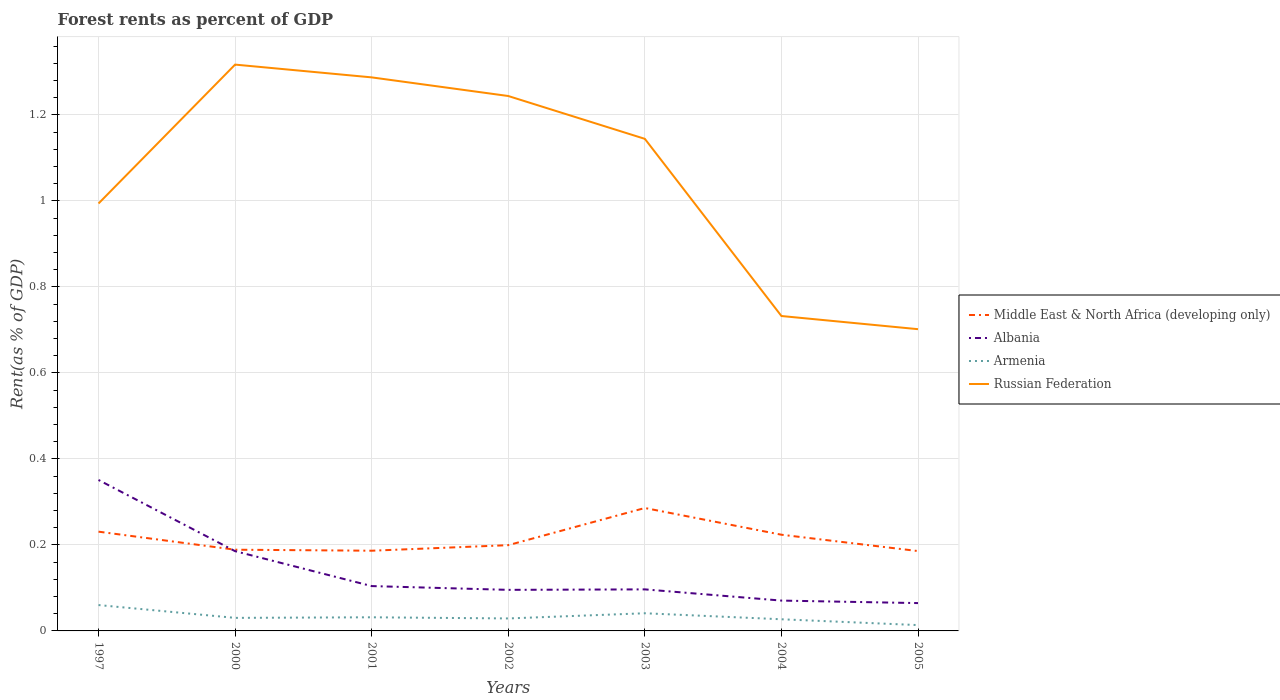Does the line corresponding to Albania intersect with the line corresponding to Russian Federation?
Offer a very short reply. No. Across all years, what is the maximum forest rent in Albania?
Your answer should be very brief. 0.06. What is the total forest rent in Russian Federation in the graph?
Offer a terse response. 0.1. What is the difference between the highest and the second highest forest rent in Middle East & North Africa (developing only)?
Keep it short and to the point. 0.1. How many years are there in the graph?
Provide a succinct answer. 7. What is the difference between two consecutive major ticks on the Y-axis?
Provide a short and direct response. 0.2. Are the values on the major ticks of Y-axis written in scientific E-notation?
Your answer should be very brief. No. How many legend labels are there?
Keep it short and to the point. 4. How are the legend labels stacked?
Offer a terse response. Vertical. What is the title of the graph?
Your response must be concise. Forest rents as percent of GDP. What is the label or title of the X-axis?
Offer a terse response. Years. What is the label or title of the Y-axis?
Your response must be concise. Rent(as % of GDP). What is the Rent(as % of GDP) in Middle East & North Africa (developing only) in 1997?
Keep it short and to the point. 0.23. What is the Rent(as % of GDP) in Albania in 1997?
Ensure brevity in your answer.  0.35. What is the Rent(as % of GDP) in Armenia in 1997?
Give a very brief answer. 0.06. What is the Rent(as % of GDP) of Russian Federation in 1997?
Provide a succinct answer. 0.99. What is the Rent(as % of GDP) in Middle East & North Africa (developing only) in 2000?
Make the answer very short. 0.19. What is the Rent(as % of GDP) in Albania in 2000?
Give a very brief answer. 0.19. What is the Rent(as % of GDP) of Armenia in 2000?
Your answer should be very brief. 0.03. What is the Rent(as % of GDP) in Russian Federation in 2000?
Provide a succinct answer. 1.32. What is the Rent(as % of GDP) in Middle East & North Africa (developing only) in 2001?
Make the answer very short. 0.19. What is the Rent(as % of GDP) in Albania in 2001?
Your response must be concise. 0.1. What is the Rent(as % of GDP) in Armenia in 2001?
Provide a succinct answer. 0.03. What is the Rent(as % of GDP) of Russian Federation in 2001?
Make the answer very short. 1.29. What is the Rent(as % of GDP) of Middle East & North Africa (developing only) in 2002?
Offer a terse response. 0.2. What is the Rent(as % of GDP) in Albania in 2002?
Keep it short and to the point. 0.1. What is the Rent(as % of GDP) in Armenia in 2002?
Give a very brief answer. 0.03. What is the Rent(as % of GDP) in Russian Federation in 2002?
Ensure brevity in your answer.  1.24. What is the Rent(as % of GDP) of Middle East & North Africa (developing only) in 2003?
Your response must be concise. 0.29. What is the Rent(as % of GDP) in Albania in 2003?
Your response must be concise. 0.1. What is the Rent(as % of GDP) of Armenia in 2003?
Make the answer very short. 0.04. What is the Rent(as % of GDP) in Russian Federation in 2003?
Make the answer very short. 1.14. What is the Rent(as % of GDP) of Middle East & North Africa (developing only) in 2004?
Provide a succinct answer. 0.22. What is the Rent(as % of GDP) in Albania in 2004?
Your answer should be compact. 0.07. What is the Rent(as % of GDP) of Armenia in 2004?
Offer a terse response. 0.03. What is the Rent(as % of GDP) in Russian Federation in 2004?
Ensure brevity in your answer.  0.73. What is the Rent(as % of GDP) of Middle East & North Africa (developing only) in 2005?
Provide a succinct answer. 0.19. What is the Rent(as % of GDP) in Albania in 2005?
Provide a short and direct response. 0.06. What is the Rent(as % of GDP) of Armenia in 2005?
Give a very brief answer. 0.01. What is the Rent(as % of GDP) in Russian Federation in 2005?
Make the answer very short. 0.7. Across all years, what is the maximum Rent(as % of GDP) of Middle East & North Africa (developing only)?
Ensure brevity in your answer.  0.29. Across all years, what is the maximum Rent(as % of GDP) in Albania?
Your response must be concise. 0.35. Across all years, what is the maximum Rent(as % of GDP) in Armenia?
Your answer should be very brief. 0.06. Across all years, what is the maximum Rent(as % of GDP) in Russian Federation?
Your response must be concise. 1.32. Across all years, what is the minimum Rent(as % of GDP) of Middle East & North Africa (developing only)?
Your answer should be compact. 0.19. Across all years, what is the minimum Rent(as % of GDP) in Albania?
Ensure brevity in your answer.  0.06. Across all years, what is the minimum Rent(as % of GDP) of Armenia?
Your response must be concise. 0.01. Across all years, what is the minimum Rent(as % of GDP) in Russian Federation?
Make the answer very short. 0.7. What is the total Rent(as % of GDP) of Middle East & North Africa (developing only) in the graph?
Your answer should be very brief. 1.5. What is the total Rent(as % of GDP) of Albania in the graph?
Provide a succinct answer. 0.97. What is the total Rent(as % of GDP) of Armenia in the graph?
Provide a succinct answer. 0.23. What is the total Rent(as % of GDP) of Russian Federation in the graph?
Make the answer very short. 7.42. What is the difference between the Rent(as % of GDP) in Middle East & North Africa (developing only) in 1997 and that in 2000?
Ensure brevity in your answer.  0.04. What is the difference between the Rent(as % of GDP) of Albania in 1997 and that in 2000?
Make the answer very short. 0.17. What is the difference between the Rent(as % of GDP) of Armenia in 1997 and that in 2000?
Your answer should be very brief. 0.03. What is the difference between the Rent(as % of GDP) of Russian Federation in 1997 and that in 2000?
Provide a succinct answer. -0.32. What is the difference between the Rent(as % of GDP) of Middle East & North Africa (developing only) in 1997 and that in 2001?
Offer a terse response. 0.04. What is the difference between the Rent(as % of GDP) of Albania in 1997 and that in 2001?
Make the answer very short. 0.25. What is the difference between the Rent(as % of GDP) in Armenia in 1997 and that in 2001?
Give a very brief answer. 0.03. What is the difference between the Rent(as % of GDP) in Russian Federation in 1997 and that in 2001?
Your answer should be very brief. -0.29. What is the difference between the Rent(as % of GDP) in Middle East & North Africa (developing only) in 1997 and that in 2002?
Your answer should be very brief. 0.03. What is the difference between the Rent(as % of GDP) in Albania in 1997 and that in 2002?
Make the answer very short. 0.26. What is the difference between the Rent(as % of GDP) in Armenia in 1997 and that in 2002?
Your answer should be compact. 0.03. What is the difference between the Rent(as % of GDP) of Middle East & North Africa (developing only) in 1997 and that in 2003?
Make the answer very short. -0.06. What is the difference between the Rent(as % of GDP) in Albania in 1997 and that in 2003?
Provide a succinct answer. 0.25. What is the difference between the Rent(as % of GDP) in Armenia in 1997 and that in 2003?
Provide a succinct answer. 0.02. What is the difference between the Rent(as % of GDP) of Russian Federation in 1997 and that in 2003?
Provide a succinct answer. -0.15. What is the difference between the Rent(as % of GDP) in Middle East & North Africa (developing only) in 1997 and that in 2004?
Your response must be concise. 0.01. What is the difference between the Rent(as % of GDP) in Albania in 1997 and that in 2004?
Make the answer very short. 0.28. What is the difference between the Rent(as % of GDP) of Armenia in 1997 and that in 2004?
Provide a succinct answer. 0.03. What is the difference between the Rent(as % of GDP) of Russian Federation in 1997 and that in 2004?
Offer a terse response. 0.26. What is the difference between the Rent(as % of GDP) of Middle East & North Africa (developing only) in 1997 and that in 2005?
Offer a terse response. 0.05. What is the difference between the Rent(as % of GDP) in Albania in 1997 and that in 2005?
Provide a short and direct response. 0.29. What is the difference between the Rent(as % of GDP) of Armenia in 1997 and that in 2005?
Provide a succinct answer. 0.05. What is the difference between the Rent(as % of GDP) of Russian Federation in 1997 and that in 2005?
Your response must be concise. 0.29. What is the difference between the Rent(as % of GDP) in Middle East & North Africa (developing only) in 2000 and that in 2001?
Make the answer very short. 0. What is the difference between the Rent(as % of GDP) in Albania in 2000 and that in 2001?
Provide a short and direct response. 0.08. What is the difference between the Rent(as % of GDP) in Armenia in 2000 and that in 2001?
Your answer should be very brief. -0. What is the difference between the Rent(as % of GDP) in Russian Federation in 2000 and that in 2001?
Your answer should be compact. 0.03. What is the difference between the Rent(as % of GDP) in Middle East & North Africa (developing only) in 2000 and that in 2002?
Provide a succinct answer. -0.01. What is the difference between the Rent(as % of GDP) of Albania in 2000 and that in 2002?
Your response must be concise. 0.09. What is the difference between the Rent(as % of GDP) in Armenia in 2000 and that in 2002?
Ensure brevity in your answer.  0. What is the difference between the Rent(as % of GDP) of Russian Federation in 2000 and that in 2002?
Provide a succinct answer. 0.07. What is the difference between the Rent(as % of GDP) in Middle East & North Africa (developing only) in 2000 and that in 2003?
Provide a short and direct response. -0.1. What is the difference between the Rent(as % of GDP) of Albania in 2000 and that in 2003?
Provide a succinct answer. 0.09. What is the difference between the Rent(as % of GDP) of Armenia in 2000 and that in 2003?
Your answer should be very brief. -0.01. What is the difference between the Rent(as % of GDP) of Russian Federation in 2000 and that in 2003?
Your answer should be very brief. 0.17. What is the difference between the Rent(as % of GDP) in Middle East & North Africa (developing only) in 2000 and that in 2004?
Provide a succinct answer. -0.03. What is the difference between the Rent(as % of GDP) in Albania in 2000 and that in 2004?
Provide a succinct answer. 0.11. What is the difference between the Rent(as % of GDP) in Armenia in 2000 and that in 2004?
Your answer should be very brief. 0. What is the difference between the Rent(as % of GDP) in Russian Federation in 2000 and that in 2004?
Offer a terse response. 0.58. What is the difference between the Rent(as % of GDP) of Middle East & North Africa (developing only) in 2000 and that in 2005?
Your response must be concise. 0. What is the difference between the Rent(as % of GDP) of Albania in 2000 and that in 2005?
Ensure brevity in your answer.  0.12. What is the difference between the Rent(as % of GDP) in Armenia in 2000 and that in 2005?
Offer a very short reply. 0.02. What is the difference between the Rent(as % of GDP) in Russian Federation in 2000 and that in 2005?
Ensure brevity in your answer.  0.62. What is the difference between the Rent(as % of GDP) of Middle East & North Africa (developing only) in 2001 and that in 2002?
Give a very brief answer. -0.01. What is the difference between the Rent(as % of GDP) in Albania in 2001 and that in 2002?
Offer a terse response. 0.01. What is the difference between the Rent(as % of GDP) of Armenia in 2001 and that in 2002?
Ensure brevity in your answer.  0. What is the difference between the Rent(as % of GDP) in Russian Federation in 2001 and that in 2002?
Keep it short and to the point. 0.04. What is the difference between the Rent(as % of GDP) in Middle East & North Africa (developing only) in 2001 and that in 2003?
Your answer should be very brief. -0.1. What is the difference between the Rent(as % of GDP) of Albania in 2001 and that in 2003?
Offer a very short reply. 0.01. What is the difference between the Rent(as % of GDP) of Armenia in 2001 and that in 2003?
Ensure brevity in your answer.  -0.01. What is the difference between the Rent(as % of GDP) of Russian Federation in 2001 and that in 2003?
Provide a short and direct response. 0.14. What is the difference between the Rent(as % of GDP) of Middle East & North Africa (developing only) in 2001 and that in 2004?
Give a very brief answer. -0.04. What is the difference between the Rent(as % of GDP) of Albania in 2001 and that in 2004?
Keep it short and to the point. 0.03. What is the difference between the Rent(as % of GDP) in Armenia in 2001 and that in 2004?
Give a very brief answer. 0. What is the difference between the Rent(as % of GDP) in Russian Federation in 2001 and that in 2004?
Your response must be concise. 0.56. What is the difference between the Rent(as % of GDP) in Middle East & North Africa (developing only) in 2001 and that in 2005?
Your response must be concise. 0. What is the difference between the Rent(as % of GDP) in Albania in 2001 and that in 2005?
Ensure brevity in your answer.  0.04. What is the difference between the Rent(as % of GDP) of Armenia in 2001 and that in 2005?
Make the answer very short. 0.02. What is the difference between the Rent(as % of GDP) in Russian Federation in 2001 and that in 2005?
Make the answer very short. 0.59. What is the difference between the Rent(as % of GDP) in Middle East & North Africa (developing only) in 2002 and that in 2003?
Keep it short and to the point. -0.09. What is the difference between the Rent(as % of GDP) of Albania in 2002 and that in 2003?
Your response must be concise. -0. What is the difference between the Rent(as % of GDP) of Armenia in 2002 and that in 2003?
Keep it short and to the point. -0.01. What is the difference between the Rent(as % of GDP) of Russian Federation in 2002 and that in 2003?
Offer a terse response. 0.1. What is the difference between the Rent(as % of GDP) in Middle East & North Africa (developing only) in 2002 and that in 2004?
Offer a very short reply. -0.02. What is the difference between the Rent(as % of GDP) of Albania in 2002 and that in 2004?
Give a very brief answer. 0.03. What is the difference between the Rent(as % of GDP) of Armenia in 2002 and that in 2004?
Provide a short and direct response. 0. What is the difference between the Rent(as % of GDP) in Russian Federation in 2002 and that in 2004?
Your response must be concise. 0.51. What is the difference between the Rent(as % of GDP) of Middle East & North Africa (developing only) in 2002 and that in 2005?
Keep it short and to the point. 0.01. What is the difference between the Rent(as % of GDP) of Albania in 2002 and that in 2005?
Offer a very short reply. 0.03. What is the difference between the Rent(as % of GDP) in Armenia in 2002 and that in 2005?
Keep it short and to the point. 0.02. What is the difference between the Rent(as % of GDP) of Russian Federation in 2002 and that in 2005?
Your answer should be very brief. 0.54. What is the difference between the Rent(as % of GDP) of Middle East & North Africa (developing only) in 2003 and that in 2004?
Your answer should be compact. 0.06. What is the difference between the Rent(as % of GDP) in Albania in 2003 and that in 2004?
Your response must be concise. 0.03. What is the difference between the Rent(as % of GDP) in Armenia in 2003 and that in 2004?
Offer a very short reply. 0.01. What is the difference between the Rent(as % of GDP) of Russian Federation in 2003 and that in 2004?
Keep it short and to the point. 0.41. What is the difference between the Rent(as % of GDP) of Middle East & North Africa (developing only) in 2003 and that in 2005?
Keep it short and to the point. 0.1. What is the difference between the Rent(as % of GDP) in Albania in 2003 and that in 2005?
Your response must be concise. 0.03. What is the difference between the Rent(as % of GDP) of Armenia in 2003 and that in 2005?
Give a very brief answer. 0.03. What is the difference between the Rent(as % of GDP) in Russian Federation in 2003 and that in 2005?
Make the answer very short. 0.44. What is the difference between the Rent(as % of GDP) in Middle East & North Africa (developing only) in 2004 and that in 2005?
Your response must be concise. 0.04. What is the difference between the Rent(as % of GDP) in Albania in 2004 and that in 2005?
Provide a short and direct response. 0.01. What is the difference between the Rent(as % of GDP) of Armenia in 2004 and that in 2005?
Give a very brief answer. 0.01. What is the difference between the Rent(as % of GDP) in Russian Federation in 2004 and that in 2005?
Offer a very short reply. 0.03. What is the difference between the Rent(as % of GDP) in Middle East & North Africa (developing only) in 1997 and the Rent(as % of GDP) in Albania in 2000?
Your answer should be very brief. 0.05. What is the difference between the Rent(as % of GDP) of Middle East & North Africa (developing only) in 1997 and the Rent(as % of GDP) of Armenia in 2000?
Give a very brief answer. 0.2. What is the difference between the Rent(as % of GDP) in Middle East & North Africa (developing only) in 1997 and the Rent(as % of GDP) in Russian Federation in 2000?
Offer a terse response. -1.09. What is the difference between the Rent(as % of GDP) in Albania in 1997 and the Rent(as % of GDP) in Armenia in 2000?
Provide a short and direct response. 0.32. What is the difference between the Rent(as % of GDP) in Albania in 1997 and the Rent(as % of GDP) in Russian Federation in 2000?
Offer a very short reply. -0.97. What is the difference between the Rent(as % of GDP) of Armenia in 1997 and the Rent(as % of GDP) of Russian Federation in 2000?
Keep it short and to the point. -1.26. What is the difference between the Rent(as % of GDP) in Middle East & North Africa (developing only) in 1997 and the Rent(as % of GDP) in Albania in 2001?
Keep it short and to the point. 0.13. What is the difference between the Rent(as % of GDP) in Middle East & North Africa (developing only) in 1997 and the Rent(as % of GDP) in Armenia in 2001?
Give a very brief answer. 0.2. What is the difference between the Rent(as % of GDP) of Middle East & North Africa (developing only) in 1997 and the Rent(as % of GDP) of Russian Federation in 2001?
Provide a short and direct response. -1.06. What is the difference between the Rent(as % of GDP) in Albania in 1997 and the Rent(as % of GDP) in Armenia in 2001?
Make the answer very short. 0.32. What is the difference between the Rent(as % of GDP) of Albania in 1997 and the Rent(as % of GDP) of Russian Federation in 2001?
Provide a succinct answer. -0.94. What is the difference between the Rent(as % of GDP) of Armenia in 1997 and the Rent(as % of GDP) of Russian Federation in 2001?
Give a very brief answer. -1.23. What is the difference between the Rent(as % of GDP) of Middle East & North Africa (developing only) in 1997 and the Rent(as % of GDP) of Albania in 2002?
Ensure brevity in your answer.  0.14. What is the difference between the Rent(as % of GDP) of Middle East & North Africa (developing only) in 1997 and the Rent(as % of GDP) of Armenia in 2002?
Provide a succinct answer. 0.2. What is the difference between the Rent(as % of GDP) of Middle East & North Africa (developing only) in 1997 and the Rent(as % of GDP) of Russian Federation in 2002?
Your answer should be very brief. -1.01. What is the difference between the Rent(as % of GDP) of Albania in 1997 and the Rent(as % of GDP) of Armenia in 2002?
Ensure brevity in your answer.  0.32. What is the difference between the Rent(as % of GDP) of Albania in 1997 and the Rent(as % of GDP) of Russian Federation in 2002?
Provide a succinct answer. -0.89. What is the difference between the Rent(as % of GDP) of Armenia in 1997 and the Rent(as % of GDP) of Russian Federation in 2002?
Offer a terse response. -1.18. What is the difference between the Rent(as % of GDP) in Middle East & North Africa (developing only) in 1997 and the Rent(as % of GDP) in Albania in 2003?
Your response must be concise. 0.13. What is the difference between the Rent(as % of GDP) in Middle East & North Africa (developing only) in 1997 and the Rent(as % of GDP) in Armenia in 2003?
Your answer should be compact. 0.19. What is the difference between the Rent(as % of GDP) in Middle East & North Africa (developing only) in 1997 and the Rent(as % of GDP) in Russian Federation in 2003?
Your answer should be compact. -0.91. What is the difference between the Rent(as % of GDP) of Albania in 1997 and the Rent(as % of GDP) of Armenia in 2003?
Offer a terse response. 0.31. What is the difference between the Rent(as % of GDP) of Albania in 1997 and the Rent(as % of GDP) of Russian Federation in 2003?
Your answer should be very brief. -0.79. What is the difference between the Rent(as % of GDP) in Armenia in 1997 and the Rent(as % of GDP) in Russian Federation in 2003?
Your response must be concise. -1.08. What is the difference between the Rent(as % of GDP) in Middle East & North Africa (developing only) in 1997 and the Rent(as % of GDP) in Albania in 2004?
Keep it short and to the point. 0.16. What is the difference between the Rent(as % of GDP) in Middle East & North Africa (developing only) in 1997 and the Rent(as % of GDP) in Armenia in 2004?
Give a very brief answer. 0.2. What is the difference between the Rent(as % of GDP) in Middle East & North Africa (developing only) in 1997 and the Rent(as % of GDP) in Russian Federation in 2004?
Keep it short and to the point. -0.5. What is the difference between the Rent(as % of GDP) of Albania in 1997 and the Rent(as % of GDP) of Armenia in 2004?
Offer a very short reply. 0.32. What is the difference between the Rent(as % of GDP) of Albania in 1997 and the Rent(as % of GDP) of Russian Federation in 2004?
Provide a short and direct response. -0.38. What is the difference between the Rent(as % of GDP) in Armenia in 1997 and the Rent(as % of GDP) in Russian Federation in 2004?
Keep it short and to the point. -0.67. What is the difference between the Rent(as % of GDP) in Middle East & North Africa (developing only) in 1997 and the Rent(as % of GDP) in Albania in 2005?
Provide a short and direct response. 0.17. What is the difference between the Rent(as % of GDP) of Middle East & North Africa (developing only) in 1997 and the Rent(as % of GDP) of Armenia in 2005?
Provide a succinct answer. 0.22. What is the difference between the Rent(as % of GDP) in Middle East & North Africa (developing only) in 1997 and the Rent(as % of GDP) in Russian Federation in 2005?
Give a very brief answer. -0.47. What is the difference between the Rent(as % of GDP) in Albania in 1997 and the Rent(as % of GDP) in Armenia in 2005?
Your answer should be compact. 0.34. What is the difference between the Rent(as % of GDP) in Albania in 1997 and the Rent(as % of GDP) in Russian Federation in 2005?
Make the answer very short. -0.35. What is the difference between the Rent(as % of GDP) of Armenia in 1997 and the Rent(as % of GDP) of Russian Federation in 2005?
Offer a terse response. -0.64. What is the difference between the Rent(as % of GDP) in Middle East & North Africa (developing only) in 2000 and the Rent(as % of GDP) in Albania in 2001?
Give a very brief answer. 0.08. What is the difference between the Rent(as % of GDP) in Middle East & North Africa (developing only) in 2000 and the Rent(as % of GDP) in Armenia in 2001?
Offer a terse response. 0.16. What is the difference between the Rent(as % of GDP) in Middle East & North Africa (developing only) in 2000 and the Rent(as % of GDP) in Russian Federation in 2001?
Provide a short and direct response. -1.1. What is the difference between the Rent(as % of GDP) in Albania in 2000 and the Rent(as % of GDP) in Armenia in 2001?
Your response must be concise. 0.15. What is the difference between the Rent(as % of GDP) of Albania in 2000 and the Rent(as % of GDP) of Russian Federation in 2001?
Provide a short and direct response. -1.1. What is the difference between the Rent(as % of GDP) in Armenia in 2000 and the Rent(as % of GDP) in Russian Federation in 2001?
Give a very brief answer. -1.26. What is the difference between the Rent(as % of GDP) in Middle East & North Africa (developing only) in 2000 and the Rent(as % of GDP) in Albania in 2002?
Offer a very short reply. 0.09. What is the difference between the Rent(as % of GDP) in Middle East & North Africa (developing only) in 2000 and the Rent(as % of GDP) in Armenia in 2002?
Give a very brief answer. 0.16. What is the difference between the Rent(as % of GDP) in Middle East & North Africa (developing only) in 2000 and the Rent(as % of GDP) in Russian Federation in 2002?
Make the answer very short. -1.06. What is the difference between the Rent(as % of GDP) in Albania in 2000 and the Rent(as % of GDP) in Armenia in 2002?
Offer a very short reply. 0.16. What is the difference between the Rent(as % of GDP) in Albania in 2000 and the Rent(as % of GDP) in Russian Federation in 2002?
Your answer should be very brief. -1.06. What is the difference between the Rent(as % of GDP) of Armenia in 2000 and the Rent(as % of GDP) of Russian Federation in 2002?
Give a very brief answer. -1.21. What is the difference between the Rent(as % of GDP) of Middle East & North Africa (developing only) in 2000 and the Rent(as % of GDP) of Albania in 2003?
Your answer should be compact. 0.09. What is the difference between the Rent(as % of GDP) of Middle East & North Africa (developing only) in 2000 and the Rent(as % of GDP) of Armenia in 2003?
Your response must be concise. 0.15. What is the difference between the Rent(as % of GDP) in Middle East & North Africa (developing only) in 2000 and the Rent(as % of GDP) in Russian Federation in 2003?
Give a very brief answer. -0.96. What is the difference between the Rent(as % of GDP) of Albania in 2000 and the Rent(as % of GDP) of Armenia in 2003?
Give a very brief answer. 0.14. What is the difference between the Rent(as % of GDP) of Albania in 2000 and the Rent(as % of GDP) of Russian Federation in 2003?
Offer a very short reply. -0.96. What is the difference between the Rent(as % of GDP) in Armenia in 2000 and the Rent(as % of GDP) in Russian Federation in 2003?
Give a very brief answer. -1.11. What is the difference between the Rent(as % of GDP) in Middle East & North Africa (developing only) in 2000 and the Rent(as % of GDP) in Albania in 2004?
Make the answer very short. 0.12. What is the difference between the Rent(as % of GDP) in Middle East & North Africa (developing only) in 2000 and the Rent(as % of GDP) in Armenia in 2004?
Give a very brief answer. 0.16. What is the difference between the Rent(as % of GDP) in Middle East & North Africa (developing only) in 2000 and the Rent(as % of GDP) in Russian Federation in 2004?
Give a very brief answer. -0.54. What is the difference between the Rent(as % of GDP) in Albania in 2000 and the Rent(as % of GDP) in Armenia in 2004?
Provide a succinct answer. 0.16. What is the difference between the Rent(as % of GDP) of Albania in 2000 and the Rent(as % of GDP) of Russian Federation in 2004?
Provide a short and direct response. -0.55. What is the difference between the Rent(as % of GDP) in Armenia in 2000 and the Rent(as % of GDP) in Russian Federation in 2004?
Ensure brevity in your answer.  -0.7. What is the difference between the Rent(as % of GDP) in Middle East & North Africa (developing only) in 2000 and the Rent(as % of GDP) in Albania in 2005?
Keep it short and to the point. 0.12. What is the difference between the Rent(as % of GDP) in Middle East & North Africa (developing only) in 2000 and the Rent(as % of GDP) in Armenia in 2005?
Your answer should be very brief. 0.18. What is the difference between the Rent(as % of GDP) in Middle East & North Africa (developing only) in 2000 and the Rent(as % of GDP) in Russian Federation in 2005?
Make the answer very short. -0.51. What is the difference between the Rent(as % of GDP) in Albania in 2000 and the Rent(as % of GDP) in Armenia in 2005?
Offer a very short reply. 0.17. What is the difference between the Rent(as % of GDP) of Albania in 2000 and the Rent(as % of GDP) of Russian Federation in 2005?
Your response must be concise. -0.52. What is the difference between the Rent(as % of GDP) in Armenia in 2000 and the Rent(as % of GDP) in Russian Federation in 2005?
Provide a succinct answer. -0.67. What is the difference between the Rent(as % of GDP) of Middle East & North Africa (developing only) in 2001 and the Rent(as % of GDP) of Albania in 2002?
Ensure brevity in your answer.  0.09. What is the difference between the Rent(as % of GDP) of Middle East & North Africa (developing only) in 2001 and the Rent(as % of GDP) of Armenia in 2002?
Offer a very short reply. 0.16. What is the difference between the Rent(as % of GDP) in Middle East & North Africa (developing only) in 2001 and the Rent(as % of GDP) in Russian Federation in 2002?
Make the answer very short. -1.06. What is the difference between the Rent(as % of GDP) in Albania in 2001 and the Rent(as % of GDP) in Armenia in 2002?
Your answer should be compact. 0.08. What is the difference between the Rent(as % of GDP) of Albania in 2001 and the Rent(as % of GDP) of Russian Federation in 2002?
Your answer should be very brief. -1.14. What is the difference between the Rent(as % of GDP) in Armenia in 2001 and the Rent(as % of GDP) in Russian Federation in 2002?
Your answer should be compact. -1.21. What is the difference between the Rent(as % of GDP) in Middle East & North Africa (developing only) in 2001 and the Rent(as % of GDP) in Albania in 2003?
Make the answer very short. 0.09. What is the difference between the Rent(as % of GDP) in Middle East & North Africa (developing only) in 2001 and the Rent(as % of GDP) in Armenia in 2003?
Your response must be concise. 0.15. What is the difference between the Rent(as % of GDP) of Middle East & North Africa (developing only) in 2001 and the Rent(as % of GDP) of Russian Federation in 2003?
Ensure brevity in your answer.  -0.96. What is the difference between the Rent(as % of GDP) of Albania in 2001 and the Rent(as % of GDP) of Armenia in 2003?
Your answer should be very brief. 0.06. What is the difference between the Rent(as % of GDP) of Albania in 2001 and the Rent(as % of GDP) of Russian Federation in 2003?
Your response must be concise. -1.04. What is the difference between the Rent(as % of GDP) in Armenia in 2001 and the Rent(as % of GDP) in Russian Federation in 2003?
Offer a terse response. -1.11. What is the difference between the Rent(as % of GDP) in Middle East & North Africa (developing only) in 2001 and the Rent(as % of GDP) in Albania in 2004?
Your answer should be very brief. 0.12. What is the difference between the Rent(as % of GDP) of Middle East & North Africa (developing only) in 2001 and the Rent(as % of GDP) of Armenia in 2004?
Your answer should be compact. 0.16. What is the difference between the Rent(as % of GDP) of Middle East & North Africa (developing only) in 2001 and the Rent(as % of GDP) of Russian Federation in 2004?
Your response must be concise. -0.55. What is the difference between the Rent(as % of GDP) in Albania in 2001 and the Rent(as % of GDP) in Armenia in 2004?
Offer a very short reply. 0.08. What is the difference between the Rent(as % of GDP) in Albania in 2001 and the Rent(as % of GDP) in Russian Federation in 2004?
Provide a succinct answer. -0.63. What is the difference between the Rent(as % of GDP) in Armenia in 2001 and the Rent(as % of GDP) in Russian Federation in 2004?
Your response must be concise. -0.7. What is the difference between the Rent(as % of GDP) in Middle East & North Africa (developing only) in 2001 and the Rent(as % of GDP) in Albania in 2005?
Offer a very short reply. 0.12. What is the difference between the Rent(as % of GDP) in Middle East & North Africa (developing only) in 2001 and the Rent(as % of GDP) in Armenia in 2005?
Keep it short and to the point. 0.17. What is the difference between the Rent(as % of GDP) in Middle East & North Africa (developing only) in 2001 and the Rent(as % of GDP) in Russian Federation in 2005?
Provide a short and direct response. -0.52. What is the difference between the Rent(as % of GDP) of Albania in 2001 and the Rent(as % of GDP) of Armenia in 2005?
Offer a terse response. 0.09. What is the difference between the Rent(as % of GDP) in Albania in 2001 and the Rent(as % of GDP) in Russian Federation in 2005?
Provide a short and direct response. -0.6. What is the difference between the Rent(as % of GDP) of Armenia in 2001 and the Rent(as % of GDP) of Russian Federation in 2005?
Ensure brevity in your answer.  -0.67. What is the difference between the Rent(as % of GDP) in Middle East & North Africa (developing only) in 2002 and the Rent(as % of GDP) in Albania in 2003?
Provide a short and direct response. 0.1. What is the difference between the Rent(as % of GDP) in Middle East & North Africa (developing only) in 2002 and the Rent(as % of GDP) in Armenia in 2003?
Provide a short and direct response. 0.16. What is the difference between the Rent(as % of GDP) in Middle East & North Africa (developing only) in 2002 and the Rent(as % of GDP) in Russian Federation in 2003?
Provide a short and direct response. -0.95. What is the difference between the Rent(as % of GDP) of Albania in 2002 and the Rent(as % of GDP) of Armenia in 2003?
Ensure brevity in your answer.  0.05. What is the difference between the Rent(as % of GDP) in Albania in 2002 and the Rent(as % of GDP) in Russian Federation in 2003?
Offer a very short reply. -1.05. What is the difference between the Rent(as % of GDP) of Armenia in 2002 and the Rent(as % of GDP) of Russian Federation in 2003?
Offer a very short reply. -1.12. What is the difference between the Rent(as % of GDP) of Middle East & North Africa (developing only) in 2002 and the Rent(as % of GDP) of Albania in 2004?
Make the answer very short. 0.13. What is the difference between the Rent(as % of GDP) in Middle East & North Africa (developing only) in 2002 and the Rent(as % of GDP) in Armenia in 2004?
Your answer should be very brief. 0.17. What is the difference between the Rent(as % of GDP) in Middle East & North Africa (developing only) in 2002 and the Rent(as % of GDP) in Russian Federation in 2004?
Offer a terse response. -0.53. What is the difference between the Rent(as % of GDP) of Albania in 2002 and the Rent(as % of GDP) of Armenia in 2004?
Your answer should be compact. 0.07. What is the difference between the Rent(as % of GDP) in Albania in 2002 and the Rent(as % of GDP) in Russian Federation in 2004?
Ensure brevity in your answer.  -0.64. What is the difference between the Rent(as % of GDP) in Armenia in 2002 and the Rent(as % of GDP) in Russian Federation in 2004?
Make the answer very short. -0.7. What is the difference between the Rent(as % of GDP) in Middle East & North Africa (developing only) in 2002 and the Rent(as % of GDP) in Albania in 2005?
Make the answer very short. 0.13. What is the difference between the Rent(as % of GDP) of Middle East & North Africa (developing only) in 2002 and the Rent(as % of GDP) of Armenia in 2005?
Give a very brief answer. 0.19. What is the difference between the Rent(as % of GDP) of Middle East & North Africa (developing only) in 2002 and the Rent(as % of GDP) of Russian Federation in 2005?
Your answer should be very brief. -0.5. What is the difference between the Rent(as % of GDP) of Albania in 2002 and the Rent(as % of GDP) of Armenia in 2005?
Give a very brief answer. 0.08. What is the difference between the Rent(as % of GDP) in Albania in 2002 and the Rent(as % of GDP) in Russian Federation in 2005?
Provide a succinct answer. -0.61. What is the difference between the Rent(as % of GDP) of Armenia in 2002 and the Rent(as % of GDP) of Russian Federation in 2005?
Offer a terse response. -0.67. What is the difference between the Rent(as % of GDP) of Middle East & North Africa (developing only) in 2003 and the Rent(as % of GDP) of Albania in 2004?
Provide a short and direct response. 0.22. What is the difference between the Rent(as % of GDP) of Middle East & North Africa (developing only) in 2003 and the Rent(as % of GDP) of Armenia in 2004?
Ensure brevity in your answer.  0.26. What is the difference between the Rent(as % of GDP) in Middle East & North Africa (developing only) in 2003 and the Rent(as % of GDP) in Russian Federation in 2004?
Give a very brief answer. -0.45. What is the difference between the Rent(as % of GDP) of Albania in 2003 and the Rent(as % of GDP) of Armenia in 2004?
Ensure brevity in your answer.  0.07. What is the difference between the Rent(as % of GDP) of Albania in 2003 and the Rent(as % of GDP) of Russian Federation in 2004?
Your response must be concise. -0.64. What is the difference between the Rent(as % of GDP) in Armenia in 2003 and the Rent(as % of GDP) in Russian Federation in 2004?
Provide a succinct answer. -0.69. What is the difference between the Rent(as % of GDP) of Middle East & North Africa (developing only) in 2003 and the Rent(as % of GDP) of Albania in 2005?
Keep it short and to the point. 0.22. What is the difference between the Rent(as % of GDP) of Middle East & North Africa (developing only) in 2003 and the Rent(as % of GDP) of Armenia in 2005?
Provide a succinct answer. 0.27. What is the difference between the Rent(as % of GDP) in Middle East & North Africa (developing only) in 2003 and the Rent(as % of GDP) in Russian Federation in 2005?
Offer a very short reply. -0.42. What is the difference between the Rent(as % of GDP) in Albania in 2003 and the Rent(as % of GDP) in Armenia in 2005?
Your answer should be very brief. 0.08. What is the difference between the Rent(as % of GDP) in Albania in 2003 and the Rent(as % of GDP) in Russian Federation in 2005?
Keep it short and to the point. -0.61. What is the difference between the Rent(as % of GDP) of Armenia in 2003 and the Rent(as % of GDP) of Russian Federation in 2005?
Your answer should be very brief. -0.66. What is the difference between the Rent(as % of GDP) in Middle East & North Africa (developing only) in 2004 and the Rent(as % of GDP) in Albania in 2005?
Make the answer very short. 0.16. What is the difference between the Rent(as % of GDP) in Middle East & North Africa (developing only) in 2004 and the Rent(as % of GDP) in Armenia in 2005?
Offer a very short reply. 0.21. What is the difference between the Rent(as % of GDP) in Middle East & North Africa (developing only) in 2004 and the Rent(as % of GDP) in Russian Federation in 2005?
Ensure brevity in your answer.  -0.48. What is the difference between the Rent(as % of GDP) of Albania in 2004 and the Rent(as % of GDP) of Armenia in 2005?
Give a very brief answer. 0.06. What is the difference between the Rent(as % of GDP) in Albania in 2004 and the Rent(as % of GDP) in Russian Federation in 2005?
Ensure brevity in your answer.  -0.63. What is the difference between the Rent(as % of GDP) of Armenia in 2004 and the Rent(as % of GDP) of Russian Federation in 2005?
Your response must be concise. -0.67. What is the average Rent(as % of GDP) of Middle East & North Africa (developing only) per year?
Offer a very short reply. 0.21. What is the average Rent(as % of GDP) in Albania per year?
Give a very brief answer. 0.14. What is the average Rent(as % of GDP) of Russian Federation per year?
Keep it short and to the point. 1.06. In the year 1997, what is the difference between the Rent(as % of GDP) in Middle East & North Africa (developing only) and Rent(as % of GDP) in Albania?
Make the answer very short. -0.12. In the year 1997, what is the difference between the Rent(as % of GDP) in Middle East & North Africa (developing only) and Rent(as % of GDP) in Armenia?
Provide a short and direct response. 0.17. In the year 1997, what is the difference between the Rent(as % of GDP) in Middle East & North Africa (developing only) and Rent(as % of GDP) in Russian Federation?
Offer a very short reply. -0.76. In the year 1997, what is the difference between the Rent(as % of GDP) in Albania and Rent(as % of GDP) in Armenia?
Provide a succinct answer. 0.29. In the year 1997, what is the difference between the Rent(as % of GDP) in Albania and Rent(as % of GDP) in Russian Federation?
Offer a very short reply. -0.64. In the year 1997, what is the difference between the Rent(as % of GDP) in Armenia and Rent(as % of GDP) in Russian Federation?
Provide a succinct answer. -0.93. In the year 2000, what is the difference between the Rent(as % of GDP) of Middle East & North Africa (developing only) and Rent(as % of GDP) of Albania?
Provide a short and direct response. 0. In the year 2000, what is the difference between the Rent(as % of GDP) of Middle East & North Africa (developing only) and Rent(as % of GDP) of Armenia?
Offer a very short reply. 0.16. In the year 2000, what is the difference between the Rent(as % of GDP) of Middle East & North Africa (developing only) and Rent(as % of GDP) of Russian Federation?
Ensure brevity in your answer.  -1.13. In the year 2000, what is the difference between the Rent(as % of GDP) in Albania and Rent(as % of GDP) in Armenia?
Your response must be concise. 0.16. In the year 2000, what is the difference between the Rent(as % of GDP) of Albania and Rent(as % of GDP) of Russian Federation?
Ensure brevity in your answer.  -1.13. In the year 2000, what is the difference between the Rent(as % of GDP) of Armenia and Rent(as % of GDP) of Russian Federation?
Give a very brief answer. -1.29. In the year 2001, what is the difference between the Rent(as % of GDP) of Middle East & North Africa (developing only) and Rent(as % of GDP) of Albania?
Keep it short and to the point. 0.08. In the year 2001, what is the difference between the Rent(as % of GDP) of Middle East & North Africa (developing only) and Rent(as % of GDP) of Armenia?
Provide a succinct answer. 0.15. In the year 2001, what is the difference between the Rent(as % of GDP) of Middle East & North Africa (developing only) and Rent(as % of GDP) of Russian Federation?
Make the answer very short. -1.1. In the year 2001, what is the difference between the Rent(as % of GDP) in Albania and Rent(as % of GDP) in Armenia?
Offer a very short reply. 0.07. In the year 2001, what is the difference between the Rent(as % of GDP) in Albania and Rent(as % of GDP) in Russian Federation?
Ensure brevity in your answer.  -1.18. In the year 2001, what is the difference between the Rent(as % of GDP) of Armenia and Rent(as % of GDP) of Russian Federation?
Ensure brevity in your answer.  -1.26. In the year 2002, what is the difference between the Rent(as % of GDP) of Middle East & North Africa (developing only) and Rent(as % of GDP) of Albania?
Provide a succinct answer. 0.1. In the year 2002, what is the difference between the Rent(as % of GDP) in Middle East & North Africa (developing only) and Rent(as % of GDP) in Armenia?
Keep it short and to the point. 0.17. In the year 2002, what is the difference between the Rent(as % of GDP) of Middle East & North Africa (developing only) and Rent(as % of GDP) of Russian Federation?
Give a very brief answer. -1.04. In the year 2002, what is the difference between the Rent(as % of GDP) in Albania and Rent(as % of GDP) in Armenia?
Give a very brief answer. 0.07. In the year 2002, what is the difference between the Rent(as % of GDP) in Albania and Rent(as % of GDP) in Russian Federation?
Your answer should be compact. -1.15. In the year 2002, what is the difference between the Rent(as % of GDP) in Armenia and Rent(as % of GDP) in Russian Federation?
Provide a succinct answer. -1.22. In the year 2003, what is the difference between the Rent(as % of GDP) in Middle East & North Africa (developing only) and Rent(as % of GDP) in Albania?
Offer a very short reply. 0.19. In the year 2003, what is the difference between the Rent(as % of GDP) in Middle East & North Africa (developing only) and Rent(as % of GDP) in Armenia?
Keep it short and to the point. 0.24. In the year 2003, what is the difference between the Rent(as % of GDP) in Middle East & North Africa (developing only) and Rent(as % of GDP) in Russian Federation?
Give a very brief answer. -0.86. In the year 2003, what is the difference between the Rent(as % of GDP) in Albania and Rent(as % of GDP) in Armenia?
Provide a short and direct response. 0.06. In the year 2003, what is the difference between the Rent(as % of GDP) in Albania and Rent(as % of GDP) in Russian Federation?
Offer a terse response. -1.05. In the year 2003, what is the difference between the Rent(as % of GDP) of Armenia and Rent(as % of GDP) of Russian Federation?
Your answer should be very brief. -1.1. In the year 2004, what is the difference between the Rent(as % of GDP) of Middle East & North Africa (developing only) and Rent(as % of GDP) of Albania?
Give a very brief answer. 0.15. In the year 2004, what is the difference between the Rent(as % of GDP) of Middle East & North Africa (developing only) and Rent(as % of GDP) of Armenia?
Make the answer very short. 0.2. In the year 2004, what is the difference between the Rent(as % of GDP) of Middle East & North Africa (developing only) and Rent(as % of GDP) of Russian Federation?
Your answer should be very brief. -0.51. In the year 2004, what is the difference between the Rent(as % of GDP) of Albania and Rent(as % of GDP) of Armenia?
Your response must be concise. 0.04. In the year 2004, what is the difference between the Rent(as % of GDP) of Albania and Rent(as % of GDP) of Russian Federation?
Your answer should be very brief. -0.66. In the year 2004, what is the difference between the Rent(as % of GDP) in Armenia and Rent(as % of GDP) in Russian Federation?
Offer a very short reply. -0.71. In the year 2005, what is the difference between the Rent(as % of GDP) in Middle East & North Africa (developing only) and Rent(as % of GDP) in Albania?
Give a very brief answer. 0.12. In the year 2005, what is the difference between the Rent(as % of GDP) of Middle East & North Africa (developing only) and Rent(as % of GDP) of Armenia?
Make the answer very short. 0.17. In the year 2005, what is the difference between the Rent(as % of GDP) of Middle East & North Africa (developing only) and Rent(as % of GDP) of Russian Federation?
Your answer should be compact. -0.52. In the year 2005, what is the difference between the Rent(as % of GDP) in Albania and Rent(as % of GDP) in Armenia?
Your answer should be compact. 0.05. In the year 2005, what is the difference between the Rent(as % of GDP) in Albania and Rent(as % of GDP) in Russian Federation?
Offer a very short reply. -0.64. In the year 2005, what is the difference between the Rent(as % of GDP) in Armenia and Rent(as % of GDP) in Russian Federation?
Provide a short and direct response. -0.69. What is the ratio of the Rent(as % of GDP) of Middle East & North Africa (developing only) in 1997 to that in 2000?
Your answer should be compact. 1.22. What is the ratio of the Rent(as % of GDP) of Albania in 1997 to that in 2000?
Provide a succinct answer. 1.89. What is the ratio of the Rent(as % of GDP) of Armenia in 1997 to that in 2000?
Give a very brief answer. 1.98. What is the ratio of the Rent(as % of GDP) in Russian Federation in 1997 to that in 2000?
Keep it short and to the point. 0.75. What is the ratio of the Rent(as % of GDP) in Middle East & North Africa (developing only) in 1997 to that in 2001?
Offer a terse response. 1.24. What is the ratio of the Rent(as % of GDP) in Albania in 1997 to that in 2001?
Offer a terse response. 3.37. What is the ratio of the Rent(as % of GDP) of Armenia in 1997 to that in 2001?
Ensure brevity in your answer.  1.9. What is the ratio of the Rent(as % of GDP) in Russian Federation in 1997 to that in 2001?
Your answer should be very brief. 0.77. What is the ratio of the Rent(as % of GDP) of Middle East & North Africa (developing only) in 1997 to that in 2002?
Keep it short and to the point. 1.16. What is the ratio of the Rent(as % of GDP) of Albania in 1997 to that in 2002?
Your answer should be compact. 3.68. What is the ratio of the Rent(as % of GDP) in Armenia in 1997 to that in 2002?
Make the answer very short. 2.07. What is the ratio of the Rent(as % of GDP) of Russian Federation in 1997 to that in 2002?
Your response must be concise. 0.8. What is the ratio of the Rent(as % of GDP) in Middle East & North Africa (developing only) in 1997 to that in 2003?
Offer a terse response. 0.81. What is the ratio of the Rent(as % of GDP) in Albania in 1997 to that in 2003?
Your answer should be compact. 3.63. What is the ratio of the Rent(as % of GDP) in Armenia in 1997 to that in 2003?
Your answer should be very brief. 1.46. What is the ratio of the Rent(as % of GDP) of Russian Federation in 1997 to that in 2003?
Provide a succinct answer. 0.87. What is the ratio of the Rent(as % of GDP) in Middle East & North Africa (developing only) in 1997 to that in 2004?
Provide a short and direct response. 1.03. What is the ratio of the Rent(as % of GDP) of Albania in 1997 to that in 2004?
Your answer should be very brief. 4.98. What is the ratio of the Rent(as % of GDP) in Armenia in 1997 to that in 2004?
Provide a short and direct response. 2.22. What is the ratio of the Rent(as % of GDP) of Russian Federation in 1997 to that in 2004?
Provide a short and direct response. 1.36. What is the ratio of the Rent(as % of GDP) in Middle East & North Africa (developing only) in 1997 to that in 2005?
Your response must be concise. 1.24. What is the ratio of the Rent(as % of GDP) of Albania in 1997 to that in 2005?
Offer a terse response. 5.42. What is the ratio of the Rent(as % of GDP) of Armenia in 1997 to that in 2005?
Keep it short and to the point. 4.44. What is the ratio of the Rent(as % of GDP) of Russian Federation in 1997 to that in 2005?
Your answer should be very brief. 1.42. What is the ratio of the Rent(as % of GDP) of Middle East & North Africa (developing only) in 2000 to that in 2001?
Offer a terse response. 1.01. What is the ratio of the Rent(as % of GDP) in Albania in 2000 to that in 2001?
Ensure brevity in your answer.  1.78. What is the ratio of the Rent(as % of GDP) in Armenia in 2000 to that in 2001?
Offer a very short reply. 0.96. What is the ratio of the Rent(as % of GDP) in Russian Federation in 2000 to that in 2001?
Your response must be concise. 1.02. What is the ratio of the Rent(as % of GDP) of Middle East & North Africa (developing only) in 2000 to that in 2002?
Your answer should be very brief. 0.95. What is the ratio of the Rent(as % of GDP) in Albania in 2000 to that in 2002?
Make the answer very short. 1.94. What is the ratio of the Rent(as % of GDP) in Armenia in 2000 to that in 2002?
Your answer should be very brief. 1.05. What is the ratio of the Rent(as % of GDP) in Russian Federation in 2000 to that in 2002?
Your answer should be compact. 1.06. What is the ratio of the Rent(as % of GDP) of Middle East & North Africa (developing only) in 2000 to that in 2003?
Make the answer very short. 0.66. What is the ratio of the Rent(as % of GDP) in Albania in 2000 to that in 2003?
Make the answer very short. 1.92. What is the ratio of the Rent(as % of GDP) of Armenia in 2000 to that in 2003?
Your response must be concise. 0.74. What is the ratio of the Rent(as % of GDP) in Russian Federation in 2000 to that in 2003?
Offer a terse response. 1.15. What is the ratio of the Rent(as % of GDP) in Middle East & North Africa (developing only) in 2000 to that in 2004?
Make the answer very short. 0.84. What is the ratio of the Rent(as % of GDP) of Albania in 2000 to that in 2004?
Your answer should be compact. 2.63. What is the ratio of the Rent(as % of GDP) in Armenia in 2000 to that in 2004?
Provide a succinct answer. 1.12. What is the ratio of the Rent(as % of GDP) of Russian Federation in 2000 to that in 2004?
Ensure brevity in your answer.  1.8. What is the ratio of the Rent(as % of GDP) in Albania in 2000 to that in 2005?
Your answer should be compact. 2.87. What is the ratio of the Rent(as % of GDP) of Armenia in 2000 to that in 2005?
Offer a very short reply. 2.24. What is the ratio of the Rent(as % of GDP) of Russian Federation in 2000 to that in 2005?
Provide a short and direct response. 1.88. What is the ratio of the Rent(as % of GDP) in Middle East & North Africa (developing only) in 2001 to that in 2002?
Give a very brief answer. 0.94. What is the ratio of the Rent(as % of GDP) in Albania in 2001 to that in 2002?
Offer a terse response. 1.09. What is the ratio of the Rent(as % of GDP) of Armenia in 2001 to that in 2002?
Your answer should be very brief. 1.09. What is the ratio of the Rent(as % of GDP) of Russian Federation in 2001 to that in 2002?
Make the answer very short. 1.03. What is the ratio of the Rent(as % of GDP) in Middle East & North Africa (developing only) in 2001 to that in 2003?
Keep it short and to the point. 0.65. What is the ratio of the Rent(as % of GDP) in Albania in 2001 to that in 2003?
Keep it short and to the point. 1.08. What is the ratio of the Rent(as % of GDP) of Armenia in 2001 to that in 2003?
Make the answer very short. 0.77. What is the ratio of the Rent(as % of GDP) of Russian Federation in 2001 to that in 2003?
Your answer should be very brief. 1.12. What is the ratio of the Rent(as % of GDP) in Middle East & North Africa (developing only) in 2001 to that in 2004?
Provide a short and direct response. 0.83. What is the ratio of the Rent(as % of GDP) of Albania in 2001 to that in 2004?
Offer a terse response. 1.48. What is the ratio of the Rent(as % of GDP) in Armenia in 2001 to that in 2004?
Your answer should be very brief. 1.17. What is the ratio of the Rent(as % of GDP) in Russian Federation in 2001 to that in 2004?
Your response must be concise. 1.76. What is the ratio of the Rent(as % of GDP) of Albania in 2001 to that in 2005?
Make the answer very short. 1.61. What is the ratio of the Rent(as % of GDP) of Armenia in 2001 to that in 2005?
Offer a very short reply. 2.34. What is the ratio of the Rent(as % of GDP) of Russian Federation in 2001 to that in 2005?
Make the answer very short. 1.83. What is the ratio of the Rent(as % of GDP) of Middle East & North Africa (developing only) in 2002 to that in 2003?
Your response must be concise. 0.7. What is the ratio of the Rent(as % of GDP) of Armenia in 2002 to that in 2003?
Keep it short and to the point. 0.71. What is the ratio of the Rent(as % of GDP) in Russian Federation in 2002 to that in 2003?
Offer a terse response. 1.09. What is the ratio of the Rent(as % of GDP) in Middle East & North Africa (developing only) in 2002 to that in 2004?
Make the answer very short. 0.89. What is the ratio of the Rent(as % of GDP) in Albania in 2002 to that in 2004?
Keep it short and to the point. 1.35. What is the ratio of the Rent(as % of GDP) of Armenia in 2002 to that in 2004?
Make the answer very short. 1.07. What is the ratio of the Rent(as % of GDP) in Russian Federation in 2002 to that in 2004?
Your response must be concise. 1.7. What is the ratio of the Rent(as % of GDP) in Middle East & North Africa (developing only) in 2002 to that in 2005?
Keep it short and to the point. 1.07. What is the ratio of the Rent(as % of GDP) in Albania in 2002 to that in 2005?
Make the answer very short. 1.48. What is the ratio of the Rent(as % of GDP) in Armenia in 2002 to that in 2005?
Make the answer very short. 2.14. What is the ratio of the Rent(as % of GDP) in Russian Federation in 2002 to that in 2005?
Offer a very short reply. 1.77. What is the ratio of the Rent(as % of GDP) in Middle East & North Africa (developing only) in 2003 to that in 2004?
Give a very brief answer. 1.28. What is the ratio of the Rent(as % of GDP) in Albania in 2003 to that in 2004?
Make the answer very short. 1.37. What is the ratio of the Rent(as % of GDP) of Armenia in 2003 to that in 2004?
Provide a short and direct response. 1.52. What is the ratio of the Rent(as % of GDP) of Russian Federation in 2003 to that in 2004?
Offer a terse response. 1.56. What is the ratio of the Rent(as % of GDP) in Middle East & North Africa (developing only) in 2003 to that in 2005?
Your answer should be very brief. 1.54. What is the ratio of the Rent(as % of GDP) of Albania in 2003 to that in 2005?
Provide a short and direct response. 1.49. What is the ratio of the Rent(as % of GDP) of Armenia in 2003 to that in 2005?
Your answer should be compact. 3.03. What is the ratio of the Rent(as % of GDP) of Russian Federation in 2003 to that in 2005?
Provide a short and direct response. 1.63. What is the ratio of the Rent(as % of GDP) in Middle East & North Africa (developing only) in 2004 to that in 2005?
Your answer should be compact. 1.2. What is the ratio of the Rent(as % of GDP) of Albania in 2004 to that in 2005?
Your answer should be very brief. 1.09. What is the ratio of the Rent(as % of GDP) in Armenia in 2004 to that in 2005?
Give a very brief answer. 2. What is the ratio of the Rent(as % of GDP) of Russian Federation in 2004 to that in 2005?
Your answer should be very brief. 1.04. What is the difference between the highest and the second highest Rent(as % of GDP) of Middle East & North Africa (developing only)?
Provide a succinct answer. 0.06. What is the difference between the highest and the second highest Rent(as % of GDP) in Albania?
Ensure brevity in your answer.  0.17. What is the difference between the highest and the second highest Rent(as % of GDP) of Armenia?
Your answer should be compact. 0.02. What is the difference between the highest and the second highest Rent(as % of GDP) in Russian Federation?
Your answer should be very brief. 0.03. What is the difference between the highest and the lowest Rent(as % of GDP) in Middle East & North Africa (developing only)?
Your answer should be very brief. 0.1. What is the difference between the highest and the lowest Rent(as % of GDP) of Albania?
Ensure brevity in your answer.  0.29. What is the difference between the highest and the lowest Rent(as % of GDP) in Armenia?
Offer a terse response. 0.05. What is the difference between the highest and the lowest Rent(as % of GDP) in Russian Federation?
Give a very brief answer. 0.62. 